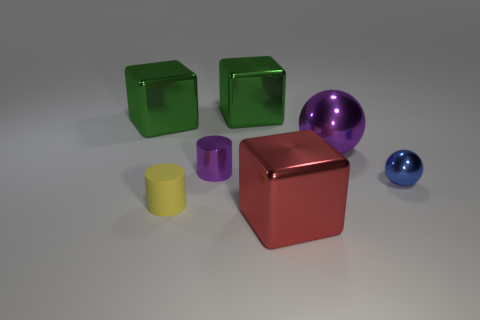Add 1 big green objects. How many objects exist? 8 Subtract all balls. How many objects are left? 5 Subtract all big yellow rubber cylinders. Subtract all red things. How many objects are left? 6 Add 3 shiny blocks. How many shiny blocks are left? 6 Add 7 big cyan rubber balls. How many big cyan rubber balls exist? 7 Subtract 0 yellow cubes. How many objects are left? 7 